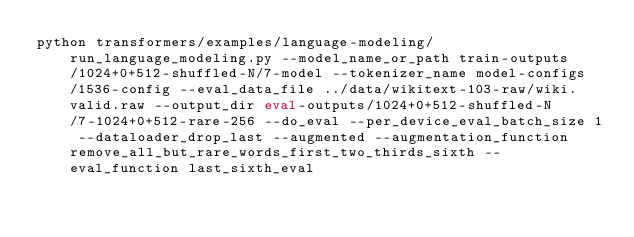Convert code to text. <code><loc_0><loc_0><loc_500><loc_500><_Bash_>python transformers/examples/language-modeling/run_language_modeling.py --model_name_or_path train-outputs/1024+0+512-shuffled-N/7-model --tokenizer_name model-configs/1536-config --eval_data_file ../data/wikitext-103-raw/wiki.valid.raw --output_dir eval-outputs/1024+0+512-shuffled-N/7-1024+0+512-rare-256 --do_eval --per_device_eval_batch_size 1 --dataloader_drop_last --augmented --augmentation_function remove_all_but_rare_words_first_two_thirds_sixth --eval_function last_sixth_eval</code> 